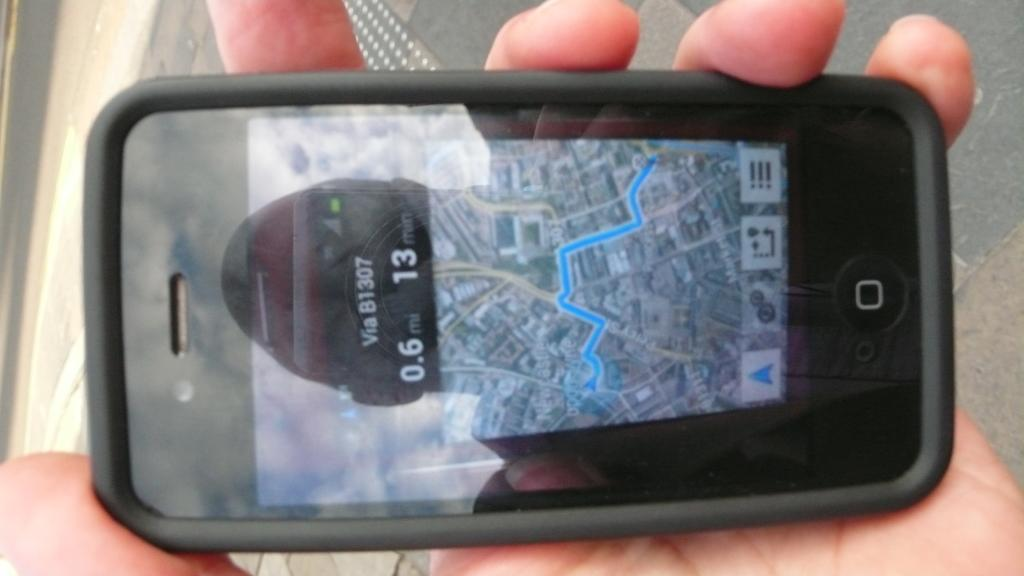Who or what is the main subject in the image? There is a person in the image. What is the person holding in their hand? The person's hand is holding a mobile. What can be seen in the distance behind the person? There is a road visible in the background of the image. How many brothers does the person in the image have? There is no information about the person's brothers in the image, so we cannot determine the number of brothers they have. 